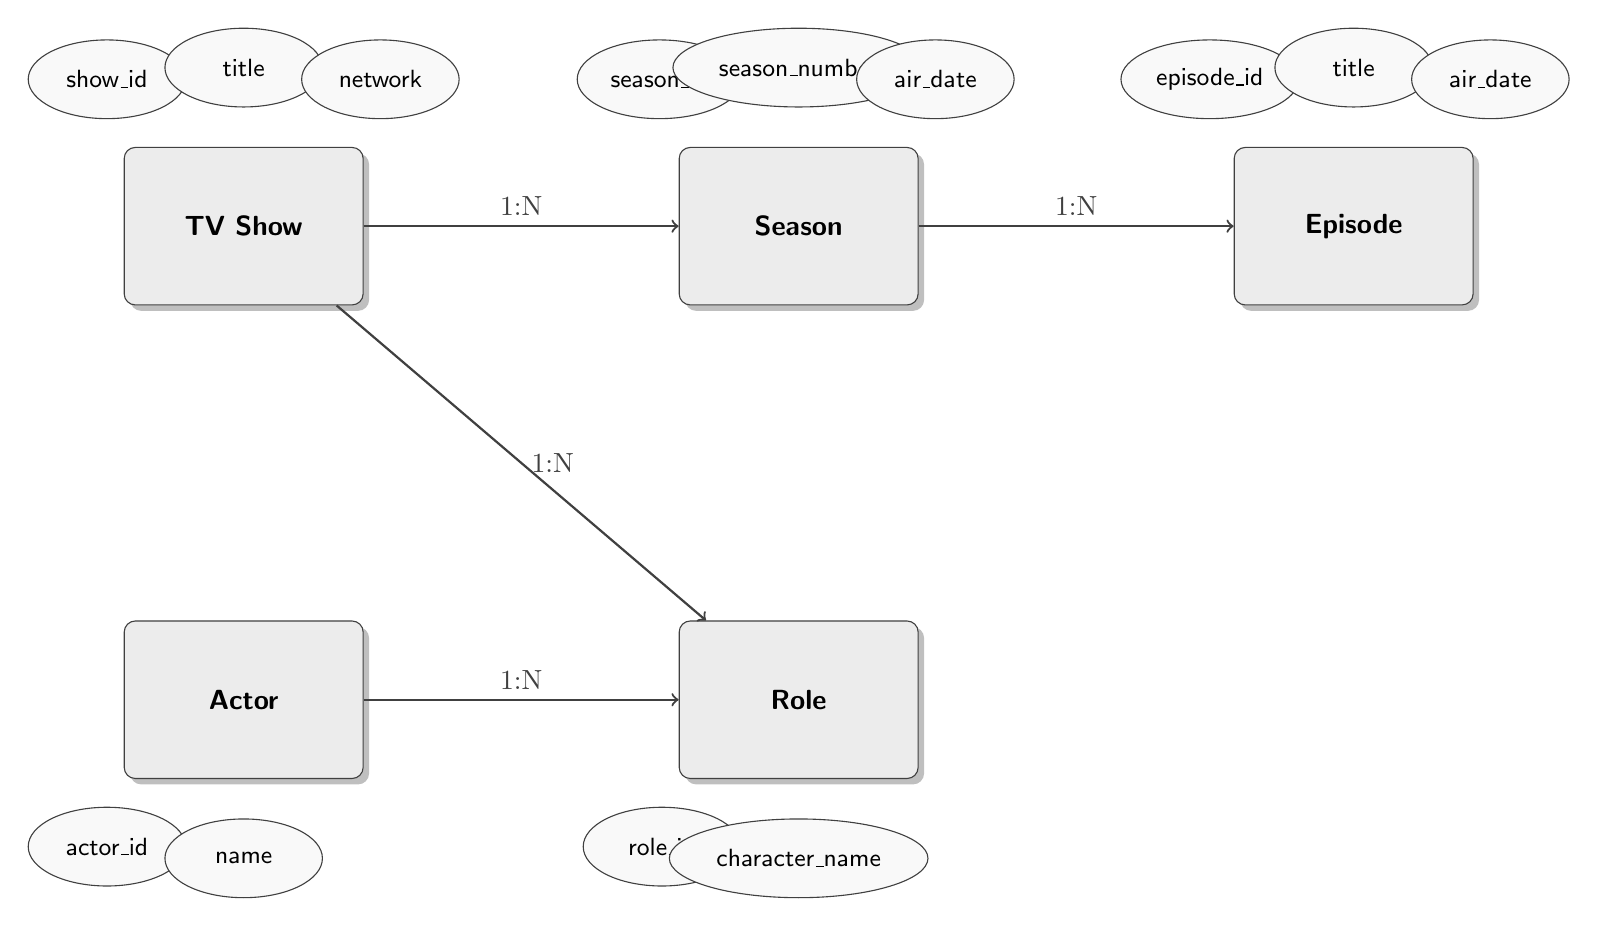What's the primary key of the TV Show entity? The diagram indicates that the primary key for the TV Show entity is "show_id." This information is found within the attributes listed under the TV Show entity.
Answer: show_id How many entities are present in the diagram? By counting the entities visually represented in the diagram, we see there are five entities: TV Show, Season, Episode, Actor, and Role.
Answer: 5 What type of relationship exists between Season and Episode? The diagram shows a "1:N" relationship between Season and Episode, meaning one Season can have multiple Episodes. This is annotated on the connecting line.
Answer: 1:N Which entity has the attribute "actor_id"? The attribute "actor_id" is listed under the Actor entity as its primary key. This can be confirmed by examining the attributes within the Actor entity box.
Answer: Actor What does the Role entity refer to in relation to Actor? The Role entity has a "1:N" relationship with the Actor entity, indicating that one Actor can play multiple Roles. This relationship is shown on the connecting line in the diagram.
Answer: 1:N What is the primary key of the Role entity? The primary key for the Role entity is "role_id," which is specified as an attribute within the Role entity box.
Answer: role_id Which entity has the "air_date" attribute? The "air_date" attribute is present in both the Season and Episode entities. We can confirm this by checking the listed attributes under each respective entity.
Answer: Season, Episode How many relationships does the Season entity have in the diagram? The Season entity has two relationships indicated in the diagram: one with TV Show and another with Episode. We can see these relationships clearly marked with arrows connected to these entities.
Answer: 2 What is the foreign key from Season to TV Show? The foreign key in the Season entity that references the TV Show entity is "show_id." This can be found in the attributes of the Season entity, where it is labeled as a foreign key referencing TV Show.
Answer: show_id 